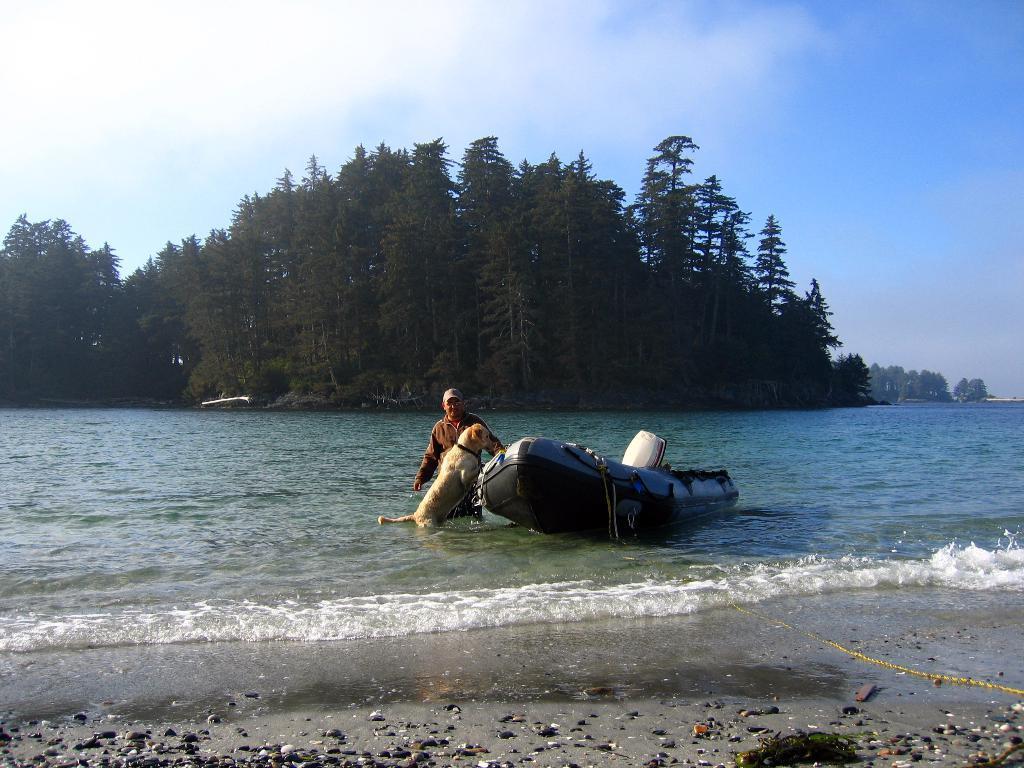Please provide a concise description of this image. In this image we can see a boat on the water. Here we can see sandstones, dog, and a person. In the background we can see trees and sky with clouds. 